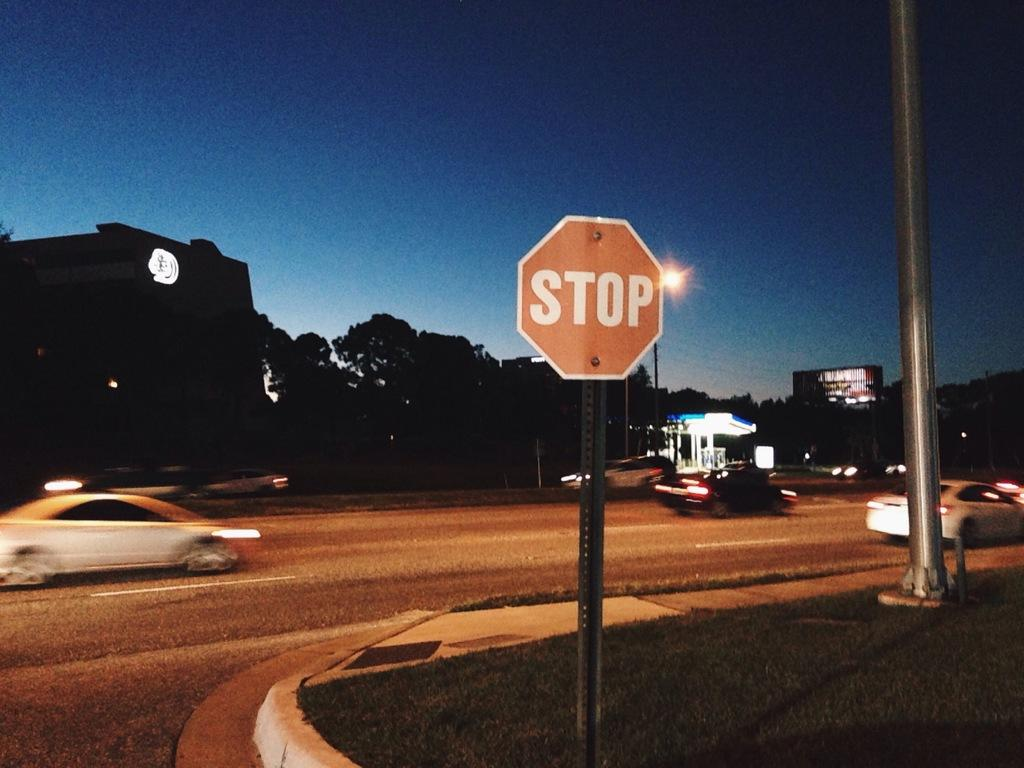<image>
Share a concise interpretation of the image provided. a stop sign that is located outside at night 